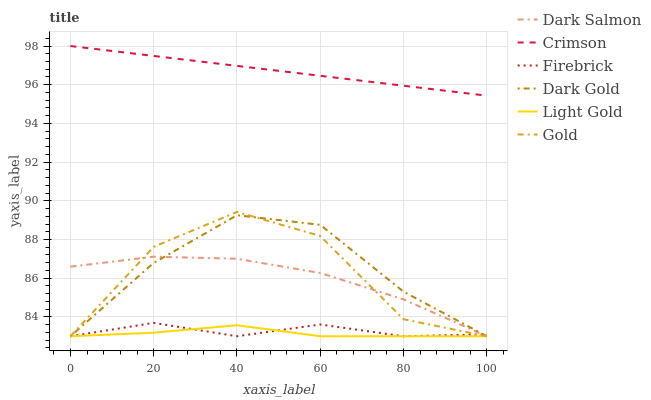Does Light Gold have the minimum area under the curve?
Answer yes or no. Yes. Does Crimson have the maximum area under the curve?
Answer yes or no. Yes. Does Dark Gold have the minimum area under the curve?
Answer yes or no. No. Does Dark Gold have the maximum area under the curve?
Answer yes or no. No. Is Crimson the smoothest?
Answer yes or no. Yes. Is Gold the roughest?
Answer yes or no. Yes. Is Dark Gold the smoothest?
Answer yes or no. No. Is Dark Gold the roughest?
Answer yes or no. No. Does Crimson have the lowest value?
Answer yes or no. No. Does Dark Gold have the highest value?
Answer yes or no. No. Is Firebrick less than Crimson?
Answer yes or no. Yes. Is Crimson greater than Dark Gold?
Answer yes or no. Yes. Does Firebrick intersect Crimson?
Answer yes or no. No. 